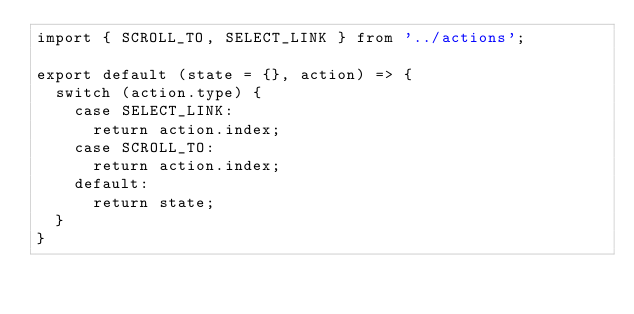<code> <loc_0><loc_0><loc_500><loc_500><_JavaScript_>import { SCROLL_TO, SELECT_LINK } from '../actions';

export default (state = {}, action) => {
  switch (action.type) {
    case SELECT_LINK:
      return action.index;
    case SCROLL_TO:
      return action.index;
    default:
      return state;
  }
}
</code> 